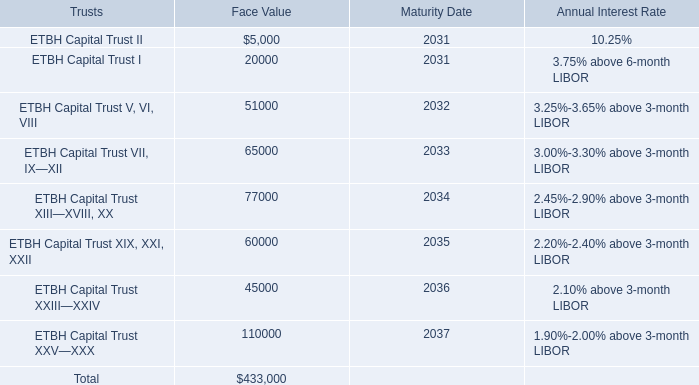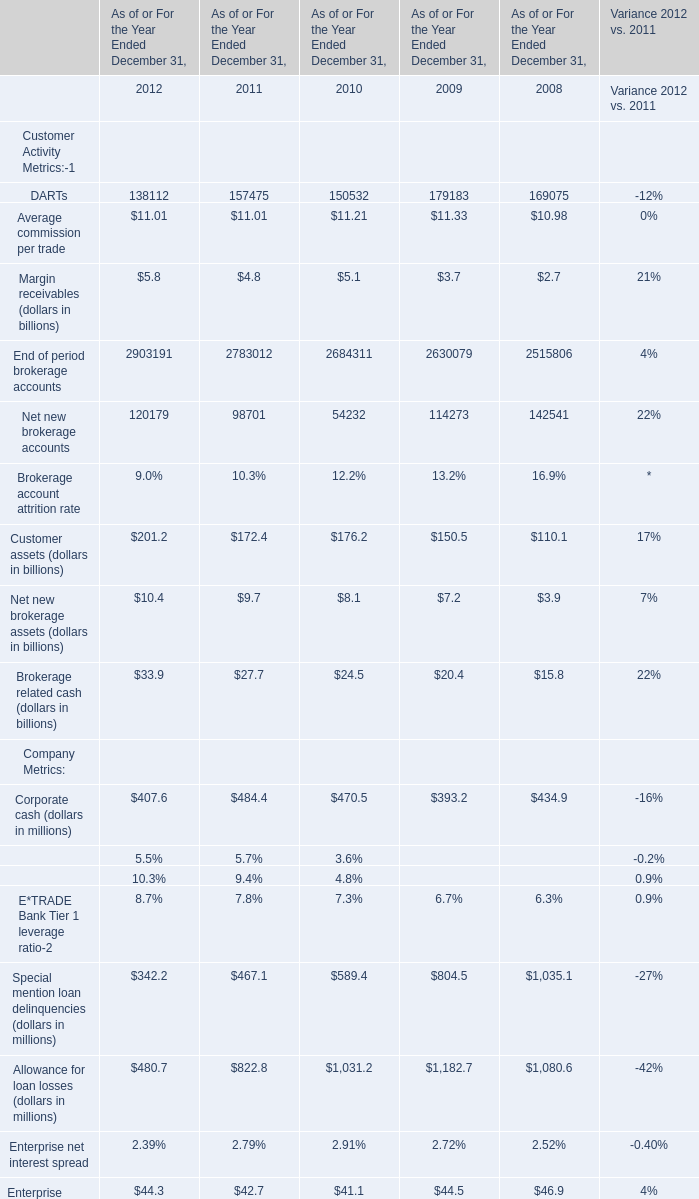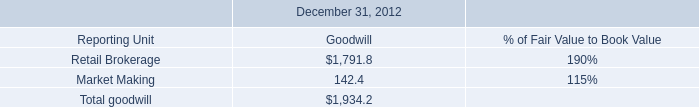what was the ratio of the company investment in fhlb stock in 2011 to 2012 
Computations: (140.2 / 67.4)
Answer: 2.08012. 